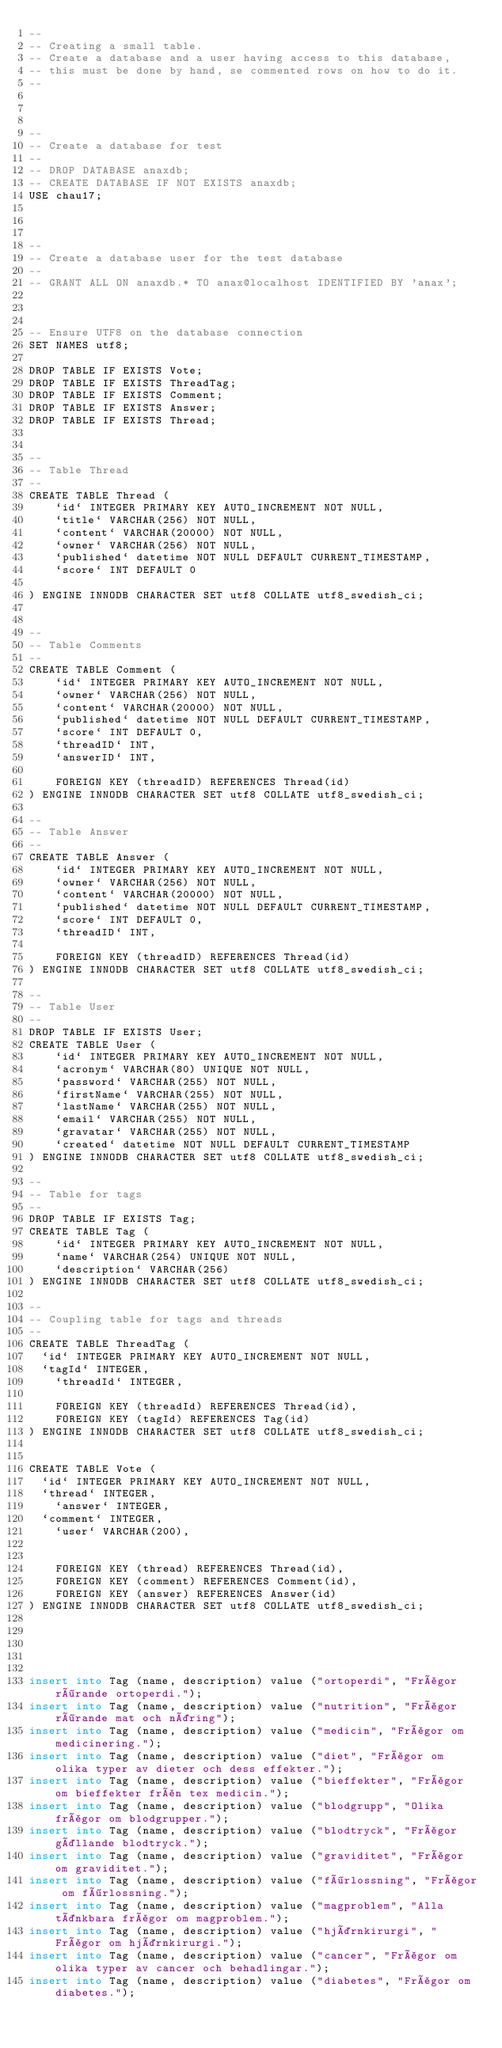Convert code to text. <code><loc_0><loc_0><loc_500><loc_500><_SQL_>--
-- Creating a small table.
-- Create a database and a user having access to this database,
-- this must be done by hand, se commented rows on how to do it.
--



--
-- Create a database for test
--
-- DROP DATABASE anaxdb;
-- CREATE DATABASE IF NOT EXISTS anaxdb;
USE chau17;



--
-- Create a database user for the test database
--
-- GRANT ALL ON anaxdb.* TO anax@localhost IDENTIFIED BY 'anax';



-- Ensure UTF8 on the database connection
SET NAMES utf8;

DROP TABLE IF EXISTS Vote;
DROP TABLE IF EXISTS ThreadTag;
DROP TABLE IF EXISTS Comment;
DROP TABLE IF EXISTS Answer;
DROP TABLE IF EXISTS Thread;


--
-- Table Thread
--
CREATE TABLE Thread (
    `id` INTEGER PRIMARY KEY AUTO_INCREMENT NOT NULL,
    `title` VARCHAR(256) NOT NULL,
    `content` VARCHAR(20000) NOT NULL,
    `owner` VARCHAR(256) NOT NULL,
    `published` datetime NOT NULL DEFAULT CURRENT_TIMESTAMP,
    `score` INT DEFAULT 0

) ENGINE INNODB CHARACTER SET utf8 COLLATE utf8_swedish_ci;


--
-- Table Comments
--
CREATE TABLE Comment (
    `id` INTEGER PRIMARY KEY AUTO_INCREMENT NOT NULL,
    `owner` VARCHAR(256) NOT NULL,
    `content` VARCHAR(20000) NOT NULL,
    `published` datetime NOT NULL DEFAULT CURRENT_TIMESTAMP,
    `score` INT DEFAULT 0,
    `threadID` INT,
    `answerID` INT,

    FOREIGN KEY (threadID) REFERENCES Thread(id)
) ENGINE INNODB CHARACTER SET utf8 COLLATE utf8_swedish_ci;

--
-- Table Answer
--
CREATE TABLE Answer (
    `id` INTEGER PRIMARY KEY AUTO_INCREMENT NOT NULL,
    `owner` VARCHAR(256) NOT NULL,
    `content` VARCHAR(20000) NOT NULL,
    `published` datetime NOT NULL DEFAULT CURRENT_TIMESTAMP,
    `score` INT DEFAULT 0,
    `threadID` INT,

    FOREIGN KEY (threadID) REFERENCES Thread(id)
) ENGINE INNODB CHARACTER SET utf8 COLLATE utf8_swedish_ci;

--
-- Table User
--
DROP TABLE IF EXISTS User;
CREATE TABLE User (
    `id` INTEGER PRIMARY KEY AUTO_INCREMENT NOT NULL,
    `acronym` VARCHAR(80) UNIQUE NOT NULL,
    `password` VARCHAR(255) NOT NULL,
    `firstName` VARCHAR(255) NOT NULL,
    `lastName` VARCHAR(255) NOT NULL,
    `email` VARCHAR(255) NOT NULL,
    `gravatar` VARCHAR(255) NOT NULL,
    `created` datetime NOT NULL DEFAULT CURRENT_TIMESTAMP
) ENGINE INNODB CHARACTER SET utf8 COLLATE utf8_swedish_ci;

--
-- Table for tags
--
DROP TABLE IF EXISTS Tag;
CREATE TABLE Tag (
    `id` INTEGER PRIMARY KEY AUTO_INCREMENT NOT NULL,
    `name` VARCHAR(254) UNIQUE NOT NULL,
    `description` VARCHAR(256)
) ENGINE INNODB CHARACTER SET utf8 COLLATE utf8_swedish_ci;

--
-- Coupling table for tags and threads
--
CREATE TABLE ThreadTag (
	`id` INTEGER PRIMARY KEY AUTO_INCREMENT NOT NULL,
	`tagId` INTEGER,
    `threadId` INTEGER,

    FOREIGN KEY (threadId) REFERENCES Thread(id),
    FOREIGN KEY (tagId) REFERENCES Tag(id)
) ENGINE INNODB CHARACTER SET utf8 COLLATE utf8_swedish_ci;


CREATE TABLE Vote (
	`id` INTEGER PRIMARY KEY AUTO_INCREMENT NOT NULL,
	`thread` INTEGER,
    `answer` INTEGER,
	`comment` INTEGER,
    `user` VARCHAR(200),


    FOREIGN KEY (thread) REFERENCES Thread(id),
    FOREIGN KEY (comment) REFERENCES Comment(id),
    FOREIGN KEY (answer) REFERENCES Answer(id)
) ENGINE INNODB CHARACTER SET utf8 COLLATE utf8_swedish_ci;





insert into Tag (name, description) value ("ortoperdi", "Frågor rörande ortoperdi.");
insert into Tag (name, description) value ("nutrition", "Frågor rörande mat och näring");
insert into Tag (name, description) value ("medicin", "Frågor om medicinering.");
insert into Tag (name, description) value ("diet", "Frågor om olika typer av dieter och dess effekter.");
insert into Tag (name, description) value ("bieffekter", "Frågor om bieffekter från tex medicin.");
insert into Tag (name, description) value ("blodgrupp", "Olika frågor om blodgrupper.");
insert into Tag (name, description) value ("blodtryck", "Frågor gällande blodtryck.");
insert into Tag (name, description) value ("graviditet", "Frågor om graviditet.");
insert into Tag (name, description) value ("förlossning", "Frågor om förlossning.");
insert into Tag (name, description) value ("magproblem", "Alla tänkbara frågor om magproblem.");
insert into Tag (name, description) value ("hjärnkirurgi", "Frågor om hjärnkirurgi.");
insert into Tag (name, description) value ("cancer", "Frågor om olika typer av cancer och behadlingar.");
insert into Tag (name, description) value ("diabetes", "Frågor om diabetes.");</code> 